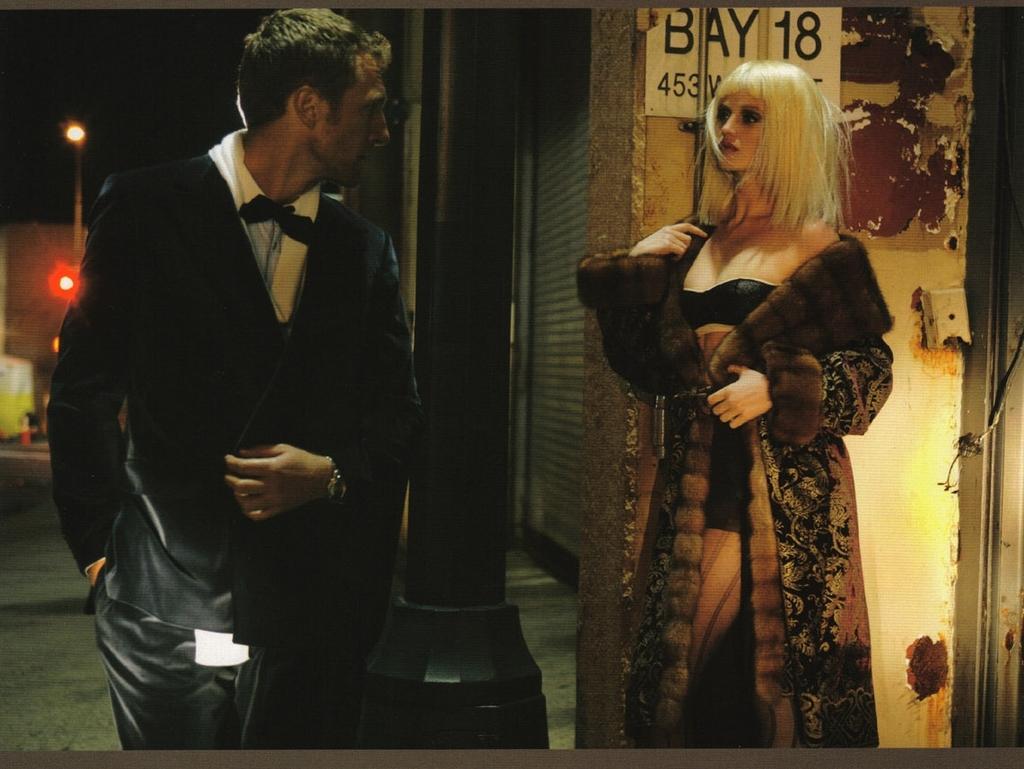Can you describe this image briefly? In this image I can see a man and a woman. In the background there is a light. 